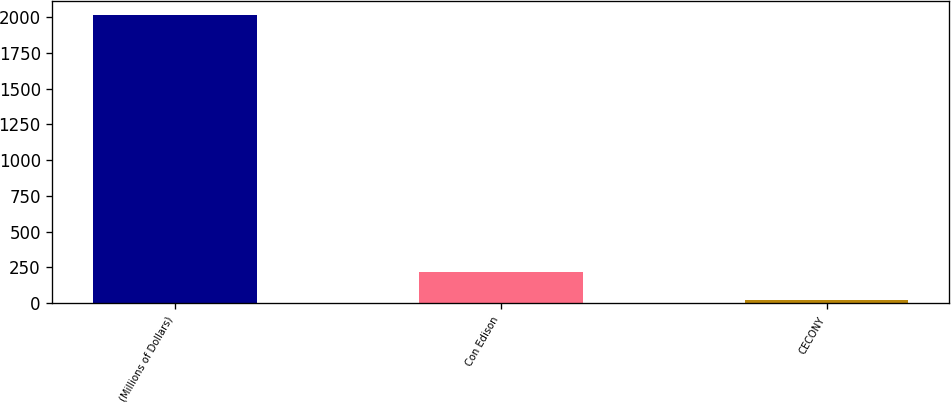Convert chart to OTSL. <chart><loc_0><loc_0><loc_500><loc_500><bar_chart><fcel>(Millions of Dollars)<fcel>Con Edison<fcel>CECONY<nl><fcel>2012<fcel>220.1<fcel>21<nl></chart> 